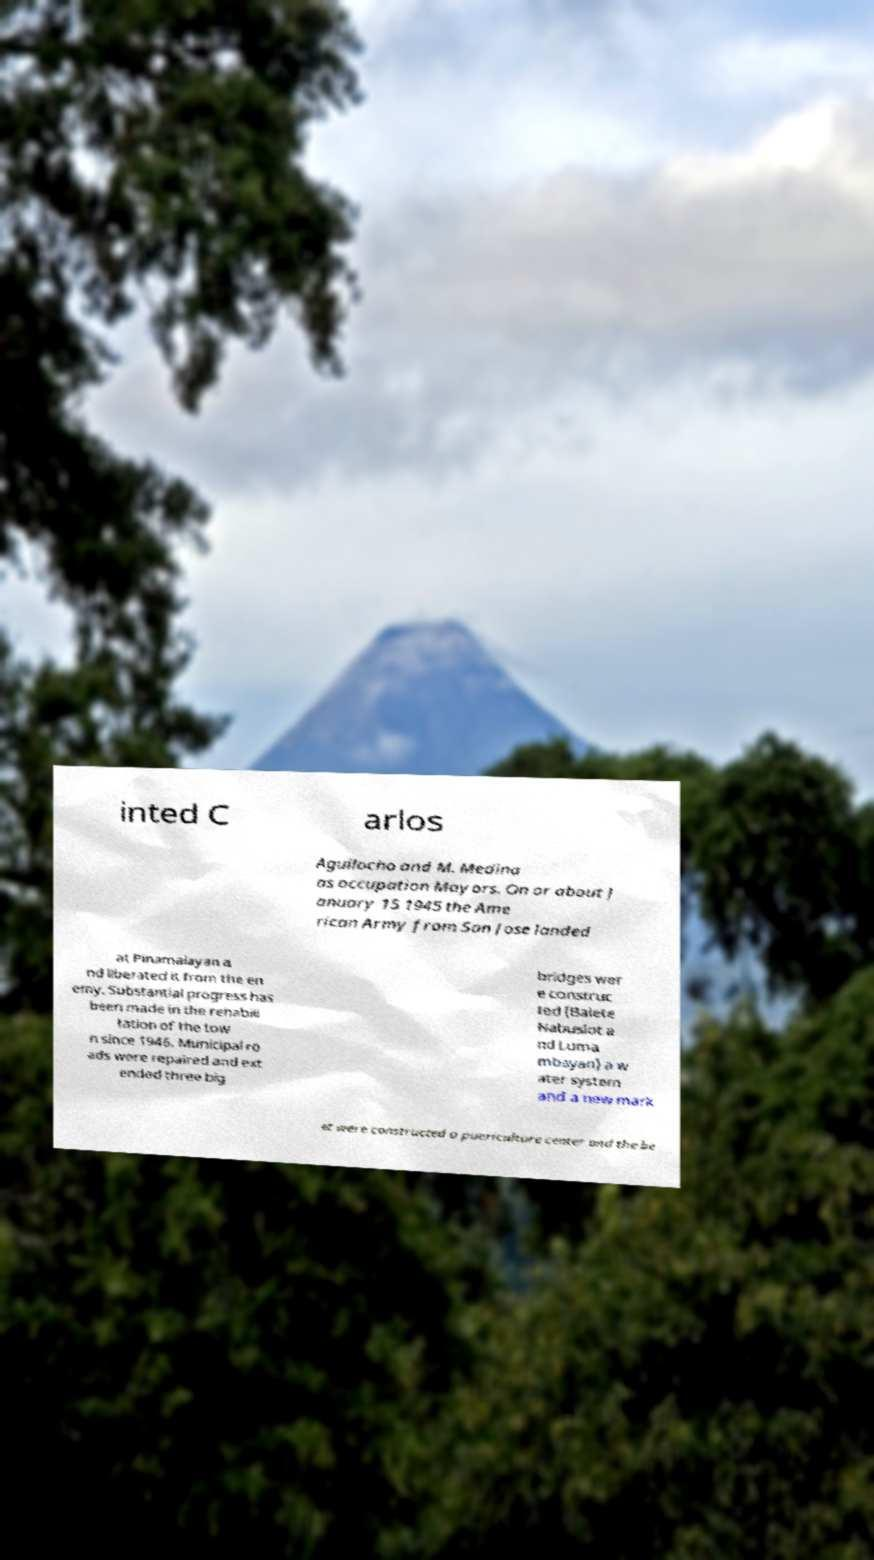For documentation purposes, I need the text within this image transcribed. Could you provide that? inted C arlos Aguilocho and M. Medina as occupation Mayors. On or about J anuary 15 1945 the Ame rican Army from San Jose landed at Pinamalayan a nd liberated it from the en emy. Substantial progress has been made in the rehabili tation of the tow n since 1946. Municipal ro ads were repaired and ext ended three big bridges wer e construc ted (Balete Nabuslot a nd Luma mbayan) a w ater system and a new mark et were constructed a puericulture center and the be 